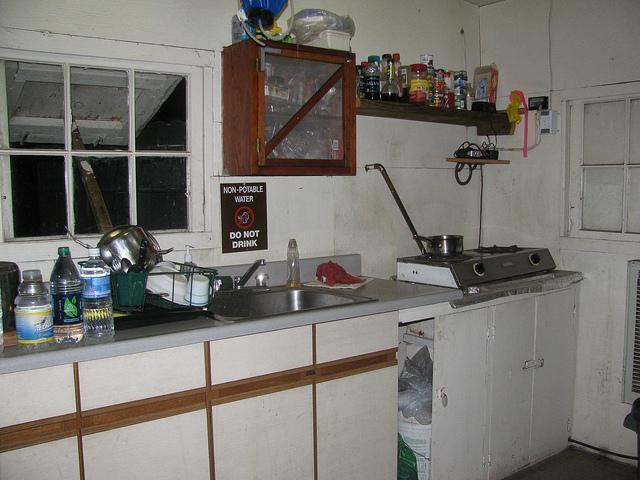How many panes are in the window?
Give a very brief answer. 6. How many bottles are there on the counter?
Give a very brief answer. 3. How many bottles are on the counter?
Give a very brief answer. 3. How many bottles can you see?
Give a very brief answer. 3. How many boats are there?
Give a very brief answer. 0. 